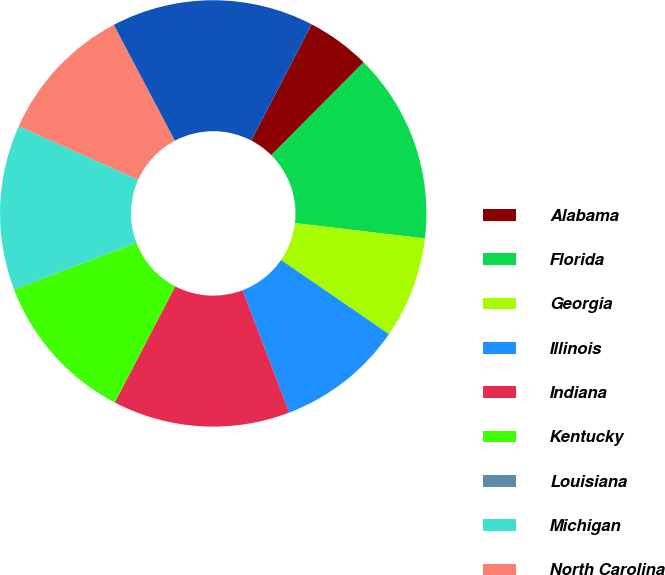Convert chart. <chart><loc_0><loc_0><loc_500><loc_500><pie_chart><fcel>Alabama<fcel>Florida<fcel>Georgia<fcel>Illinois<fcel>Indiana<fcel>Kentucky<fcel>Louisiana<fcel>Michigan<fcel>North Carolina<fcel>Ohio<nl><fcel>4.83%<fcel>14.41%<fcel>7.7%<fcel>9.62%<fcel>13.45%<fcel>11.53%<fcel>0.04%<fcel>12.49%<fcel>10.57%<fcel>15.36%<nl></chart> 